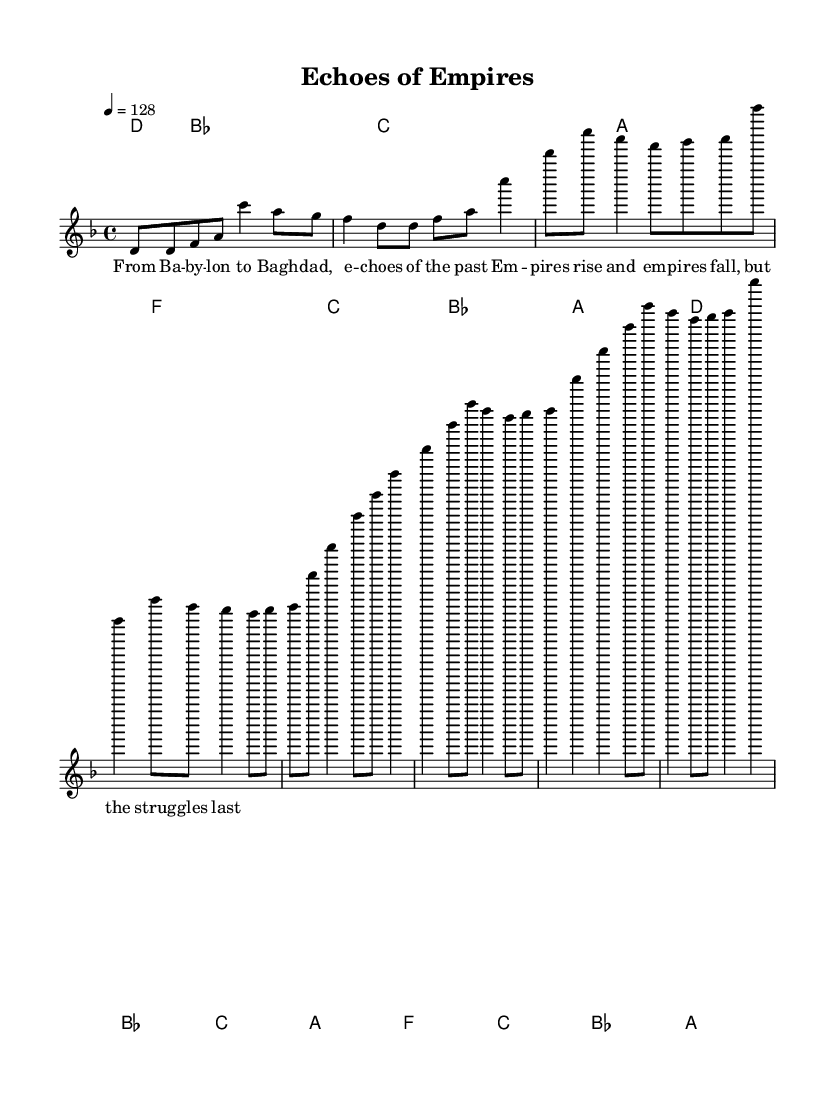What is the key signature of this music? The key signature is D minor, which contains one flat (B flat). This is indicated at the beginning of the score.
Answer: D minor What is the time signature of this music? The time signature is 4/4, which denotes four beats in a measure. This is specified at the beginning of the score.
Answer: 4/4 What is the tempo of this piece? The tempo marking indicates a speed of 128 beats per minute, which is noted as '4 = 128' at the beginning of the score.
Answer: 128 How many measures are in the verse section? The verse contains four measures, quantified by counting the notation segments in the verse portion of the score.
Answer: 4 What chord follows the F major chord in the pre-chorus? The chord sequence indicates that the chord following F major chord is C major in the pre-chorus. This is evident in the harmony line after F major.
Answer: C major Which historical cities are referenced in the lyrics? The lyrics mention Babylon and Baghdad as historical cities, clearly stated in the verse section of the lyrics provided.
Answer: Babylon, Baghdad What unique thematic element is highlighted in the chorus? The chorus reflects the theme of empires rising and falling, an important aspect highlighted in the lyrics, demonstrating historical struggle and continuity.
Answer: Empires 